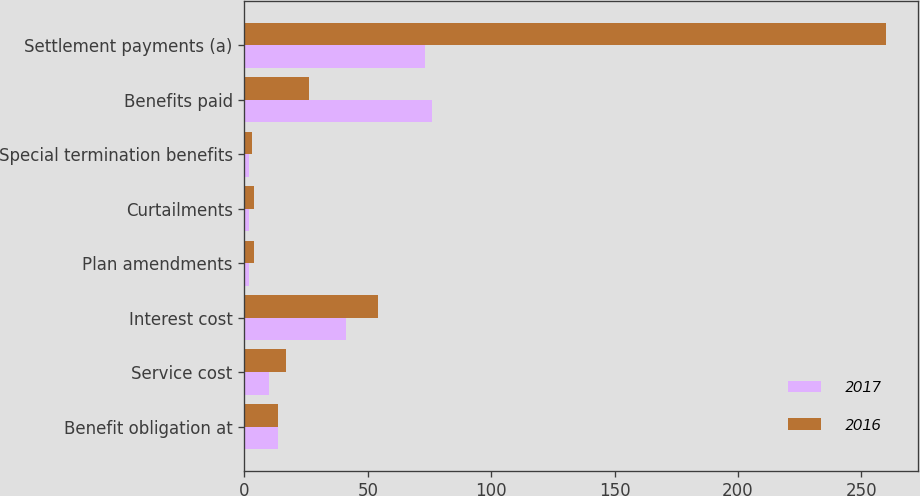Convert chart to OTSL. <chart><loc_0><loc_0><loc_500><loc_500><stacked_bar_chart><ecel><fcel>Benefit obligation at<fcel>Service cost<fcel>Interest cost<fcel>Plan amendments<fcel>Curtailments<fcel>Special termination benefits<fcel>Benefits paid<fcel>Settlement payments (a)<nl><fcel>2017<fcel>13.5<fcel>10<fcel>41<fcel>2<fcel>2<fcel>2<fcel>76<fcel>73<nl><fcel>2016<fcel>13.5<fcel>17<fcel>54<fcel>4<fcel>4<fcel>3<fcel>26<fcel>260<nl></chart> 